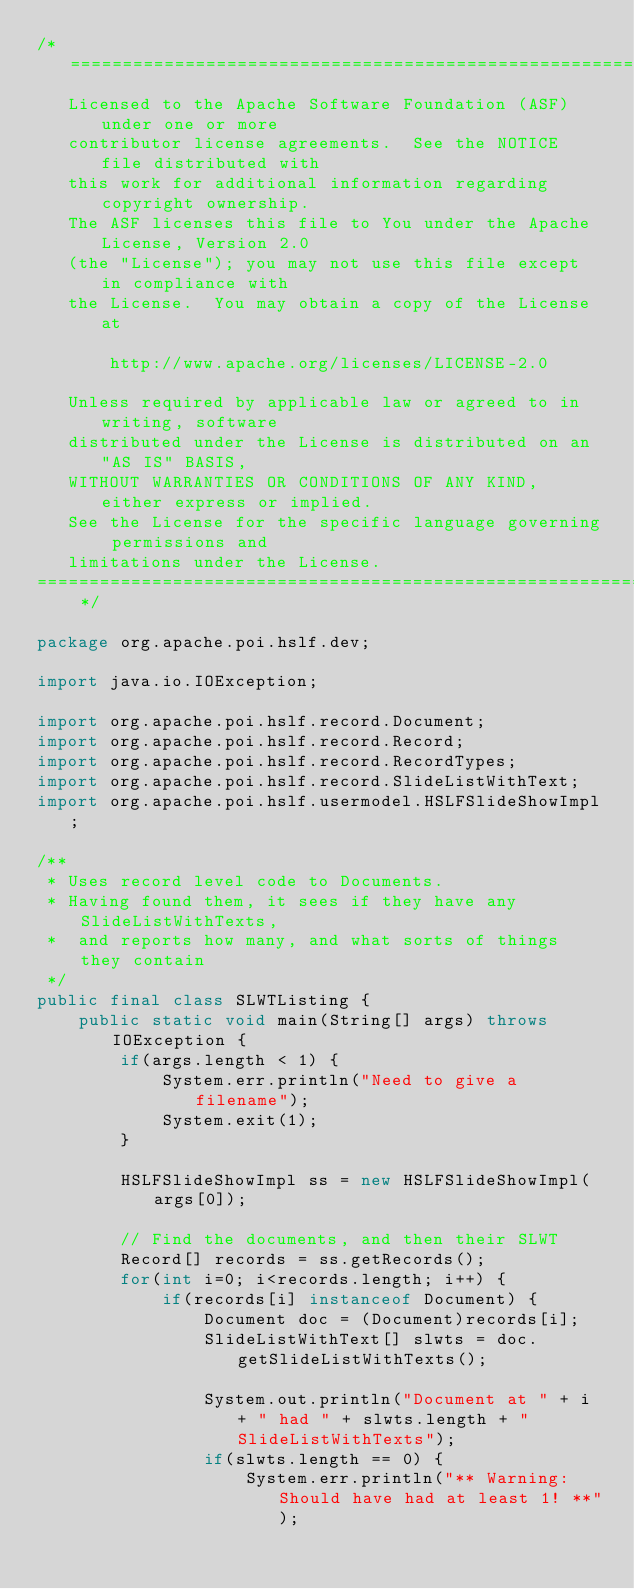<code> <loc_0><loc_0><loc_500><loc_500><_Java_>/* ====================================================================
   Licensed to the Apache Software Foundation (ASF) under one or more
   contributor license agreements.  See the NOTICE file distributed with
   this work for additional information regarding copyright ownership.
   The ASF licenses this file to You under the Apache License, Version 2.0
   (the "License"); you may not use this file except in compliance with
   the License.  You may obtain a copy of the License at

       http://www.apache.org/licenses/LICENSE-2.0

   Unless required by applicable law or agreed to in writing, software
   distributed under the License is distributed on an "AS IS" BASIS,
   WITHOUT WARRANTIES OR CONDITIONS OF ANY KIND, either express or implied.
   See the License for the specific language governing permissions and
   limitations under the License.
==================================================================== */

package org.apache.poi.hslf.dev;

import java.io.IOException;

import org.apache.poi.hslf.record.Document;
import org.apache.poi.hslf.record.Record;
import org.apache.poi.hslf.record.RecordTypes;
import org.apache.poi.hslf.record.SlideListWithText;
import org.apache.poi.hslf.usermodel.HSLFSlideShowImpl;

/**
 * Uses record level code to Documents.
 * Having found them, it sees if they have any SlideListWithTexts,
 *  and reports how many, and what sorts of things they contain
 */
public final class SLWTListing {
	public static void main(String[] args) throws IOException {
		if(args.length < 1) {
			System.err.println("Need to give a filename");
			System.exit(1);
		}

		HSLFSlideShowImpl ss = new HSLFSlideShowImpl(args[0]);

		// Find the documents, and then their SLWT
		Record[] records = ss.getRecords();
		for(int i=0; i<records.length; i++) {
			if(records[i] instanceof Document) {
				Document doc = (Document)records[i];
				SlideListWithText[] slwts = doc.getSlideListWithTexts();

				System.out.println("Document at " + i + " had " + slwts.length + " SlideListWithTexts");
				if(slwts.length == 0) {
					System.err.println("** Warning: Should have had at least 1! **");</code> 